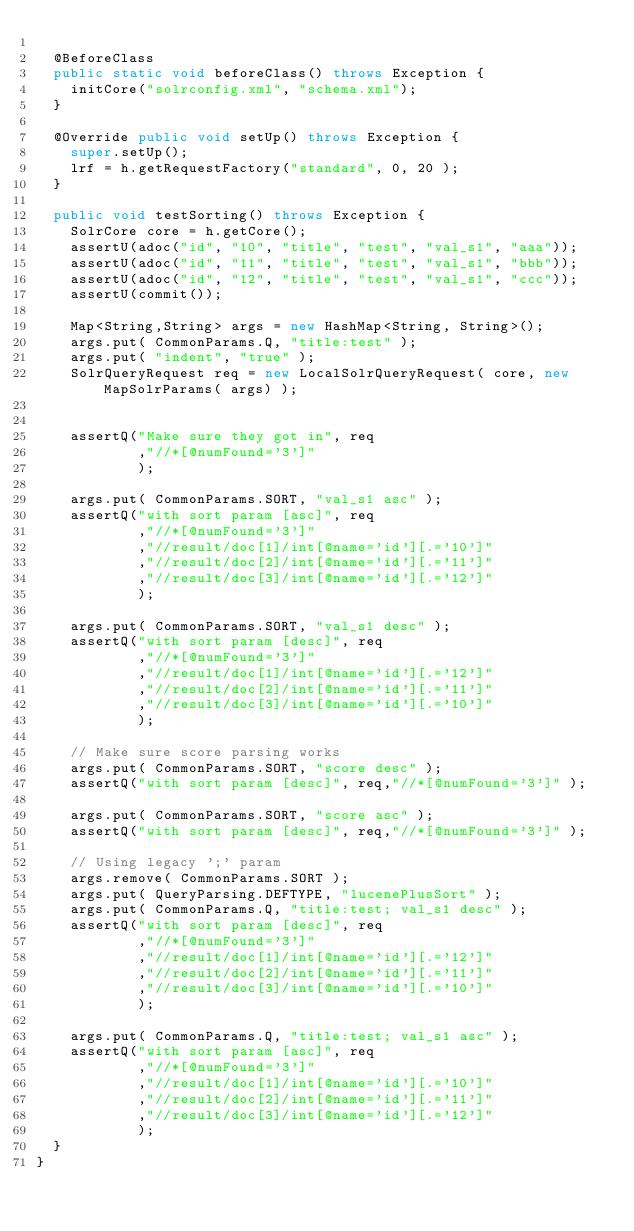<code> <loc_0><loc_0><loc_500><loc_500><_Java_>  
  @BeforeClass
  public static void beforeClass() throws Exception {
    initCore("solrconfig.xml", "schema.xml");
  }
  
  @Override public void setUp() throws Exception {
    super.setUp();
    lrf = h.getRequestFactory("standard", 0, 20 );
  }
  
  public void testSorting() throws Exception {
    SolrCore core = h.getCore();
    assertU(adoc("id", "10", "title", "test", "val_s1", "aaa"));
    assertU(adoc("id", "11", "title", "test", "val_s1", "bbb"));
    assertU(adoc("id", "12", "title", "test", "val_s1", "ccc"));
    assertU(commit());
    
    Map<String,String> args = new HashMap<String, String>();
    args.put( CommonParams.Q, "title:test" );
    args.put( "indent", "true" );
    SolrQueryRequest req = new LocalSolrQueryRequest( core, new MapSolrParams( args) );
    
    
    assertQ("Make sure they got in", req
            ,"//*[@numFound='3']"
            );
    
    args.put( CommonParams.SORT, "val_s1 asc" );
    assertQ("with sort param [asc]", req
            ,"//*[@numFound='3']"
            ,"//result/doc[1]/int[@name='id'][.='10']"
            ,"//result/doc[2]/int[@name='id'][.='11']"
            ,"//result/doc[3]/int[@name='id'][.='12']"
            );

    args.put( CommonParams.SORT, "val_s1 desc" );
    assertQ("with sort param [desc]", req
            ,"//*[@numFound='3']"
            ,"//result/doc[1]/int[@name='id'][.='12']"
            ,"//result/doc[2]/int[@name='id'][.='11']"
            ,"//result/doc[3]/int[@name='id'][.='10']"
            );
    
    // Make sure score parsing works
    args.put( CommonParams.SORT, "score desc" );
    assertQ("with sort param [desc]", req,"//*[@numFound='3']" );

    args.put( CommonParams.SORT, "score asc" );
    assertQ("with sort param [desc]", req,"//*[@numFound='3']" );
    
    // Using legacy ';' param
    args.remove( CommonParams.SORT );
    args.put( QueryParsing.DEFTYPE, "lucenePlusSort" );
    args.put( CommonParams.Q, "title:test; val_s1 desc" );
    assertQ("with sort param [desc]", req
            ,"//*[@numFound='3']"
            ,"//result/doc[1]/int[@name='id'][.='12']"
            ,"//result/doc[2]/int[@name='id'][.='11']"
            ,"//result/doc[3]/int[@name='id'][.='10']"
            );

    args.put( CommonParams.Q, "title:test; val_s1 asc" );
    assertQ("with sort param [asc]", req
            ,"//*[@numFound='3']"
            ,"//result/doc[1]/int[@name='id'][.='10']"
            ,"//result/doc[2]/int[@name='id'][.='11']"
            ,"//result/doc[3]/int[@name='id'][.='12']"
            );
  }
}
</code> 